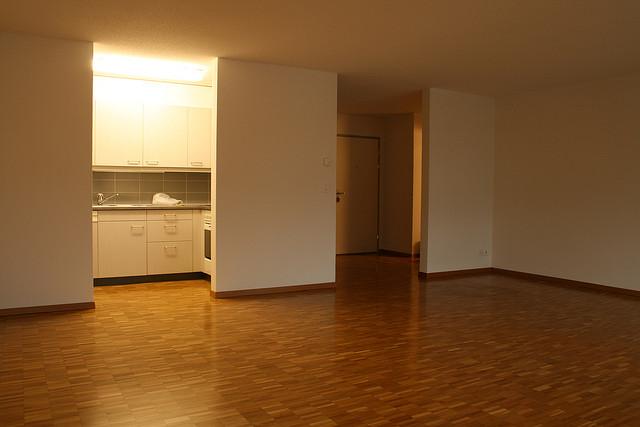How many doorways are pictured in the room?
Be succinct. 2. Are there lights hanging from the ceiling?
Answer briefly. No. What is the white object on the kitchen counter?
Be succinct. Towel. What color is the wall?
Be succinct. White. Is this a wood burning fireplace?
Quick response, please. No. Is this a business or residence?
Concise answer only. Residence. Does this house get good sunlight?
Keep it brief. No. Why is there dish detergent on the ground?
Concise answer only. It fell. How many electrical outlets are on the walls?
Give a very brief answer. 1. Is there a television?
Short answer required. No. 